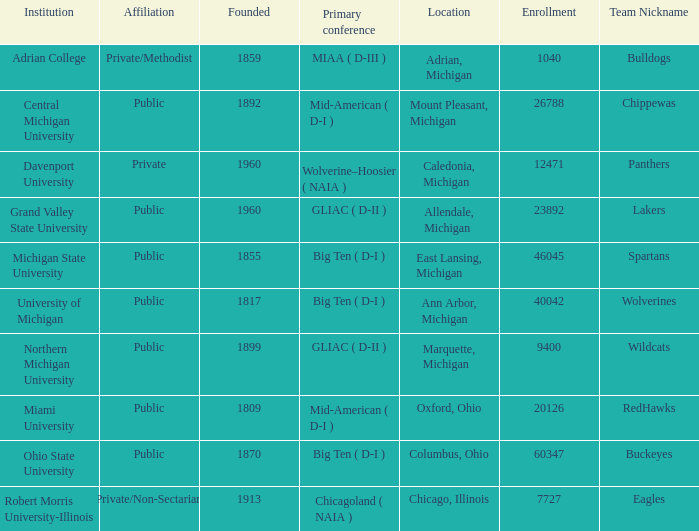Give me the full table as a dictionary. {'header': ['Institution', 'Affiliation', 'Founded', 'Primary conference', 'Location', 'Enrollment', 'Team Nickname'], 'rows': [['Adrian College', 'Private/Methodist', '1859', 'MIAA ( D-III )', 'Adrian, Michigan', '1040', 'Bulldogs'], ['Central Michigan University', 'Public', '1892', 'Mid-American ( D-I )', 'Mount Pleasant, Michigan', '26788', 'Chippewas'], ['Davenport University', 'Private', '1960', 'Wolverine–Hoosier ( NAIA )', 'Caledonia, Michigan', '12471', 'Panthers'], ['Grand Valley State University', 'Public', '1960', 'GLIAC ( D-II )', 'Allendale, Michigan', '23892', 'Lakers'], ['Michigan State University', 'Public', '1855', 'Big Ten ( D-I )', 'East Lansing, Michigan', '46045', 'Spartans'], ['University of Michigan', 'Public', '1817', 'Big Ten ( D-I )', 'Ann Arbor, Michigan', '40042', 'Wolverines'], ['Northern Michigan University', 'Public', '1899', 'GLIAC ( D-II )', 'Marquette, Michigan', '9400', 'Wildcats'], ['Miami University', 'Public', '1809', 'Mid-American ( D-I )', 'Oxford, Ohio', '20126', 'RedHawks'], ['Ohio State University', 'Public', '1870', 'Big Ten ( D-I )', 'Columbus, Ohio', '60347', 'Buckeyes'], ['Robert Morris University-Illinois', 'Private/Non-Sectarian', '1913', 'Chicagoland ( NAIA )', 'Chicago, Illinois', '7727', 'Eagles']]} What is the nickname of the Adrian, Michigan team? Bulldogs. 